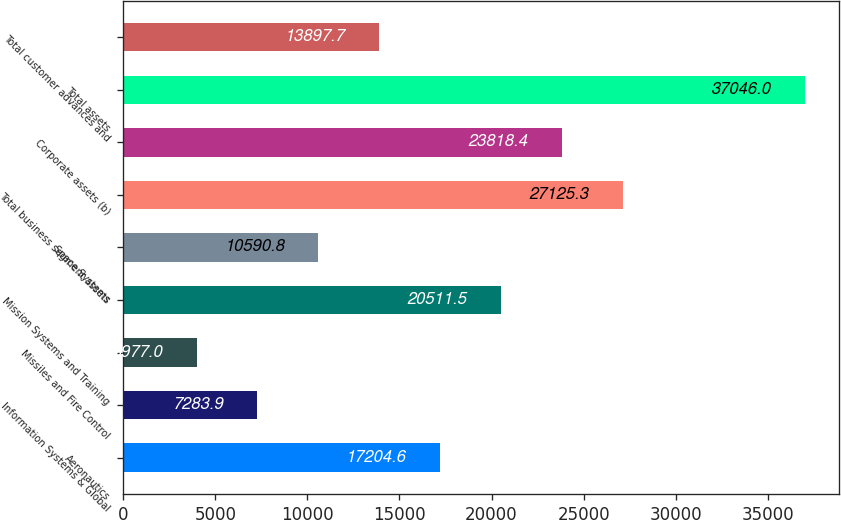Convert chart. <chart><loc_0><loc_0><loc_500><loc_500><bar_chart><fcel>Aeronautics<fcel>Information Systems & Global<fcel>Missiles and Fire Control<fcel>Mission Systems and Training<fcel>Space Systems<fcel>Total business segment assets<fcel>Corporate assets (b)<fcel>Total assets<fcel>Total customer advances and<nl><fcel>17204.6<fcel>7283.9<fcel>3977<fcel>20511.5<fcel>10590.8<fcel>27125.3<fcel>23818.4<fcel>37046<fcel>13897.7<nl></chart> 